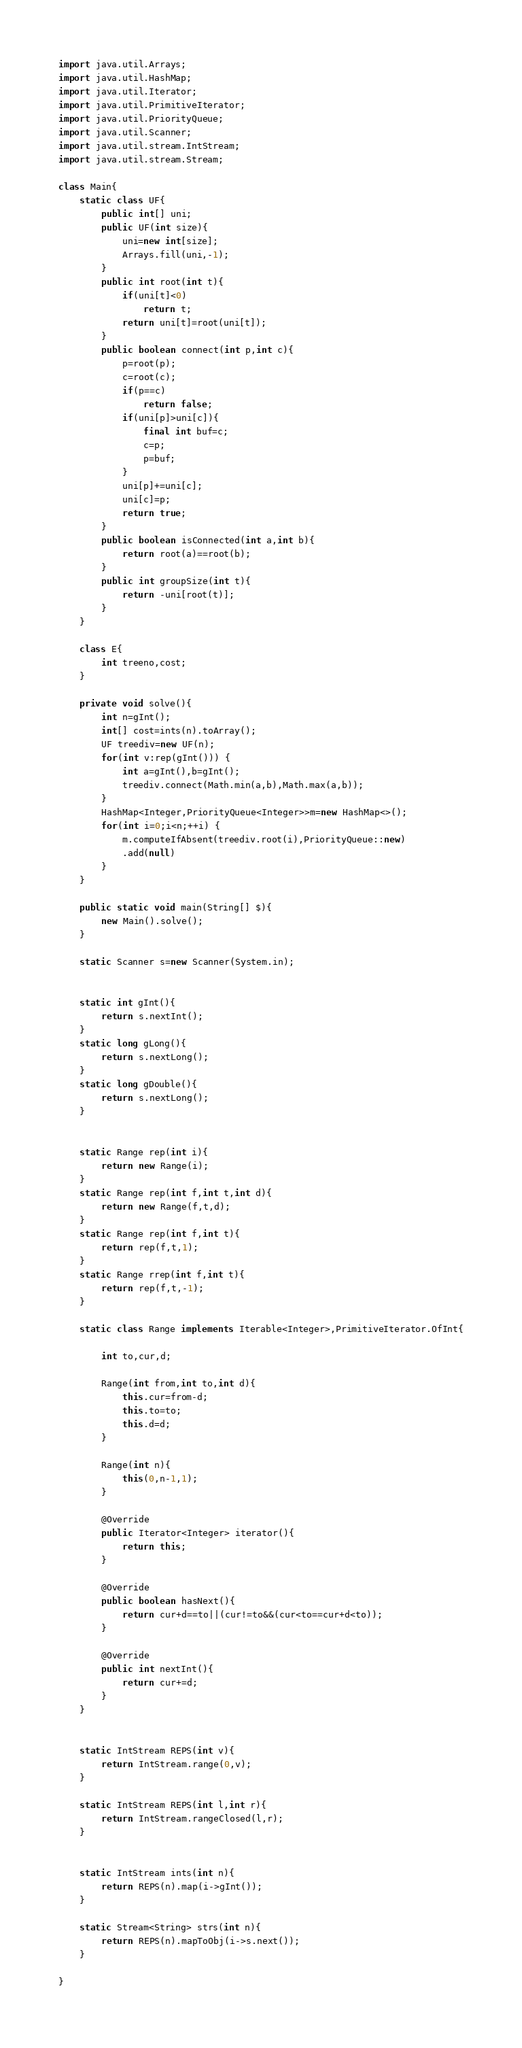Convert code to text. <code><loc_0><loc_0><loc_500><loc_500><_Java_>import java.util.Arrays;
import java.util.HashMap;
import java.util.Iterator;
import java.util.PrimitiveIterator;
import java.util.PriorityQueue;
import java.util.Scanner;
import java.util.stream.IntStream;
import java.util.stream.Stream;

class Main{
	static class UF{
		public int[] uni;
		public UF(int size){
			uni=new int[size];
			Arrays.fill(uni,-1);
		}
		public int root(int t){
			if(uni[t]<0)
				return t;
			return uni[t]=root(uni[t]);
		}
		public boolean connect(int p,int c){
			p=root(p);
			c=root(c);
			if(p==c)
				return false;
			if(uni[p]>uni[c]){
				final int buf=c;
				c=p;
				p=buf;
			}
			uni[p]+=uni[c];
			uni[c]=p;
			return true;
		}
		public boolean isConnected(int a,int b){
			return root(a)==root(b);
		}
		public int groupSize(int t){
			return -uni[root(t)];
		}
	}

	class E{
		int treeno,cost;
	}

	private void solve(){
		int n=gInt();
		int[] cost=ints(n).toArray();
		UF treediv=new UF(n);
		for(int v:rep(gInt())) {
			int a=gInt(),b=gInt();
			treediv.connect(Math.min(a,b),Math.max(a,b));
		}
		HashMap<Integer,PriorityQueue<Integer>>m=new HashMap<>();
		for(int i=0;i<n;++i) {
			m.computeIfAbsent(treediv.root(i),PriorityQueue::new)
			.add(null)
		}
	}

	public static void main(String[] $){
		new Main().solve();
	}

	static Scanner s=new Scanner(System.in);


	static int gInt(){
		return s.nextInt();
	}
	static long gLong(){
		return s.nextLong();
	}
	static long gDouble(){
		return s.nextLong();
	}


	static Range rep(int i){
		return new Range(i);
	}
	static Range rep(int f,int t,int d){
		return new Range(f,t,d);
	}
	static Range rep(int f,int t){
		return rep(f,t,1);
	}
	static Range rrep(int f,int t){
		return rep(f,t,-1);
	}

	static class Range implements Iterable<Integer>,PrimitiveIterator.OfInt{

		int to,cur,d;

		Range(int from,int to,int d){
			this.cur=from-d;
			this.to=to;
			this.d=d;
		}

		Range(int n){
			this(0,n-1,1);
		}

		@Override
		public Iterator<Integer> iterator(){
			return this;
		}

		@Override
		public boolean hasNext(){
			return cur+d==to||(cur!=to&&(cur<to==cur+d<to));
		}

		@Override
		public int nextInt(){
			return cur+=d;
		}
	}


	static IntStream REPS(int v){
		return IntStream.range(0,v);
	}

	static IntStream REPS(int l,int r){
		return IntStream.rangeClosed(l,r);
	}


	static IntStream ints(int n){
		return REPS(n).map(i->gInt());
	}

	static Stream<String> strs(int n){
		return REPS(n).mapToObj(i->s.next());
	}

}</code> 